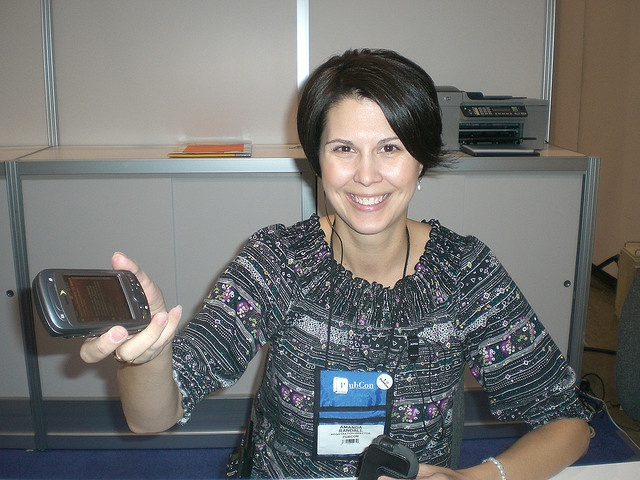Describe the objects in this image and their specific colors. I can see people in gray, black, and darkgray tones, cell phone in gray and black tones, and chair in gray, black, purple, and darkblue tones in this image. 